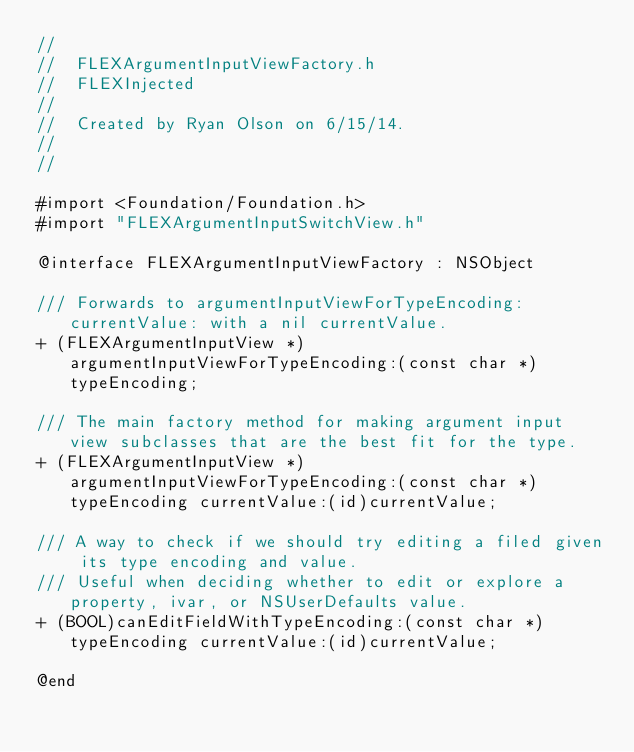<code> <loc_0><loc_0><loc_500><loc_500><_C_>//
//  FLEXArgumentInputViewFactory.h
//  FLEXInjected
//
//  Created by Ryan Olson on 6/15/14.
//
//

#import <Foundation/Foundation.h>
#import "FLEXArgumentInputSwitchView.h"

@interface FLEXArgumentInputViewFactory : NSObject

/// Forwards to argumentInputViewForTypeEncoding:currentValue: with a nil currentValue.
+ (FLEXArgumentInputView *)argumentInputViewForTypeEncoding:(const char *)typeEncoding;

/// The main factory method for making argument input view subclasses that are the best fit for the type.
+ (FLEXArgumentInputView *)argumentInputViewForTypeEncoding:(const char *)typeEncoding currentValue:(id)currentValue;

/// A way to check if we should try editing a filed given its type encoding and value.
/// Useful when deciding whether to edit or explore a property, ivar, or NSUserDefaults value.
+ (BOOL)canEditFieldWithTypeEncoding:(const char *)typeEncoding currentValue:(id)currentValue;

@end
</code> 